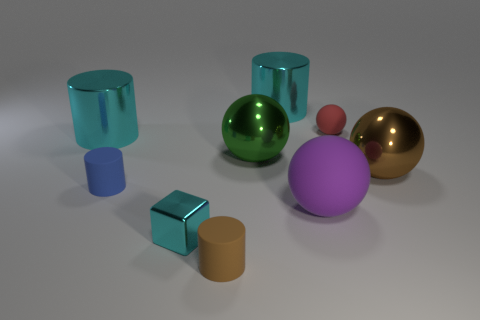What is the material of the red sphere that is the same size as the brown matte object?
Offer a very short reply. Rubber. Is the shape of the green shiny thing the same as the small blue rubber object?
Your answer should be compact. No. How many things are either large purple matte balls or cylinders that are on the left side of the tiny cyan shiny block?
Your answer should be compact. 3. Does the metal cylinder right of the blue object have the same size as the tiny metallic cube?
Offer a terse response. No. There is a cyan thing that is in front of the big metallic cylinder left of the small blue rubber thing; how many tiny matte cylinders are on the left side of it?
Your answer should be very brief. 1. What number of green objects are large cylinders or tiny things?
Provide a succinct answer. 0. What is the color of the big sphere that is made of the same material as the small red thing?
Make the answer very short. Purple. Are there any other things that have the same size as the purple matte ball?
Ensure brevity in your answer.  Yes. How many tiny objects are either blue objects or brown cylinders?
Make the answer very short. 2. Is the number of tiny red objects less than the number of large metal things?
Ensure brevity in your answer.  Yes. 